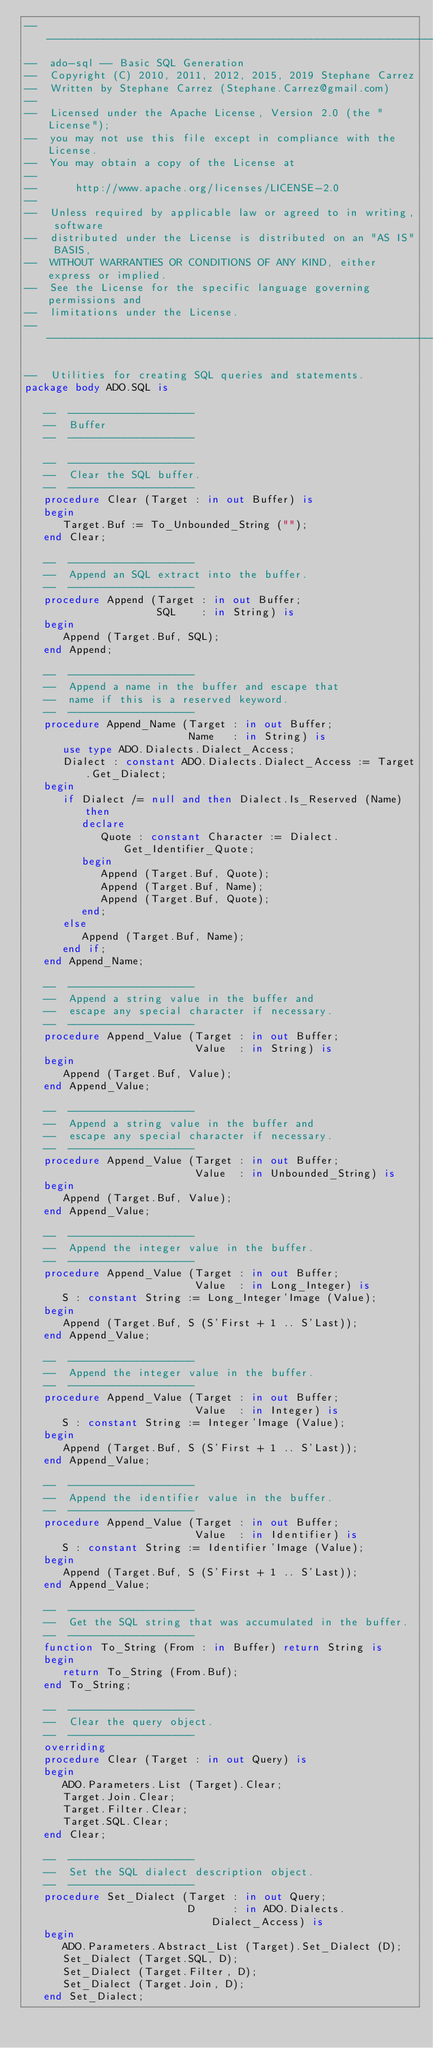<code> <loc_0><loc_0><loc_500><loc_500><_Ada_>-----------------------------------------------------------------------
--  ado-sql -- Basic SQL Generation
--  Copyright (C) 2010, 2011, 2012, 2015, 2019 Stephane Carrez
--  Written by Stephane Carrez (Stephane.Carrez@gmail.com)
--
--  Licensed under the Apache License, Version 2.0 (the "License");
--  you may not use this file except in compliance with the License.
--  You may obtain a copy of the License at
--
--      http://www.apache.org/licenses/LICENSE-2.0
--
--  Unless required by applicable law or agreed to in writing, software
--  distributed under the License is distributed on an "AS IS" BASIS,
--  WITHOUT WARRANTIES OR CONDITIONS OF ANY KIND, either express or implied.
--  See the License for the specific language governing permissions and
--  limitations under the License.
-----------------------------------------------------------------------

--  Utilities for creating SQL queries and statements.
package body ADO.SQL is

   --  --------------------
   --  Buffer
   --  --------------------

   --  --------------------
   --  Clear the SQL buffer.
   --  --------------------
   procedure Clear (Target : in out Buffer) is
   begin
      Target.Buf := To_Unbounded_String ("");
   end Clear;

   --  --------------------
   --  Append an SQL extract into the buffer.
   --  --------------------
   procedure Append (Target : in out Buffer;
                     SQL    : in String) is
   begin
      Append (Target.Buf, SQL);
   end Append;

   --  --------------------
   --  Append a name in the buffer and escape that
   --  name if this is a reserved keyword.
   --  --------------------
   procedure Append_Name (Target : in out Buffer;
                          Name   : in String) is
      use type ADO.Dialects.Dialect_Access;
      Dialect : constant ADO.Dialects.Dialect_Access := Target.Get_Dialect;
   begin
      if Dialect /= null and then Dialect.Is_Reserved (Name) then
         declare
            Quote : constant Character := Dialect.Get_Identifier_Quote;
         begin
            Append (Target.Buf, Quote);
            Append (Target.Buf, Name);
            Append (Target.Buf, Quote);
         end;
      else
         Append (Target.Buf, Name);
      end if;
   end Append_Name;

   --  --------------------
   --  Append a string value in the buffer and
   --  escape any special character if necessary.
   --  --------------------
   procedure Append_Value (Target : in out Buffer;
                           Value  : in String) is
   begin
      Append (Target.Buf, Value);
   end Append_Value;

   --  --------------------
   --  Append a string value in the buffer and
   --  escape any special character if necessary.
   --  --------------------
   procedure Append_Value (Target : in out Buffer;
                           Value  : in Unbounded_String) is
   begin
      Append (Target.Buf, Value);
   end Append_Value;

   --  --------------------
   --  Append the integer value in the buffer.
   --  --------------------
   procedure Append_Value (Target : in out Buffer;
                           Value  : in Long_Integer) is
      S : constant String := Long_Integer'Image (Value);
   begin
      Append (Target.Buf, S (S'First + 1 .. S'Last));
   end Append_Value;

   --  --------------------
   --  Append the integer value in the buffer.
   --  --------------------
   procedure Append_Value (Target : in out Buffer;
                           Value  : in Integer) is
      S : constant String := Integer'Image (Value);
   begin
      Append (Target.Buf, S (S'First + 1 .. S'Last));
   end Append_Value;

   --  --------------------
   --  Append the identifier value in the buffer.
   --  --------------------
   procedure Append_Value (Target : in out Buffer;
                           Value  : in Identifier) is
      S : constant String := Identifier'Image (Value);
   begin
      Append (Target.Buf, S (S'First + 1 .. S'Last));
   end Append_Value;

   --  --------------------
   --  Get the SQL string that was accumulated in the buffer.
   --  --------------------
   function To_String (From : in Buffer) return String is
   begin
      return To_String (From.Buf);
   end To_String;

   --  --------------------
   --  Clear the query object.
   --  --------------------
   overriding
   procedure Clear (Target : in out Query) is
   begin
      ADO.Parameters.List (Target).Clear;
      Target.Join.Clear;
      Target.Filter.Clear;
      Target.SQL.Clear;
   end Clear;

   --  --------------------
   --  Set the SQL dialect description object.
   --  --------------------
   procedure Set_Dialect (Target : in out Query;
                          D      : in ADO.Dialects.Dialect_Access) is
   begin
      ADO.Parameters.Abstract_List (Target).Set_Dialect (D);
      Set_Dialect (Target.SQL, D);
      Set_Dialect (Target.Filter, D);
      Set_Dialect (Target.Join, D);
   end Set_Dialect;
</code> 